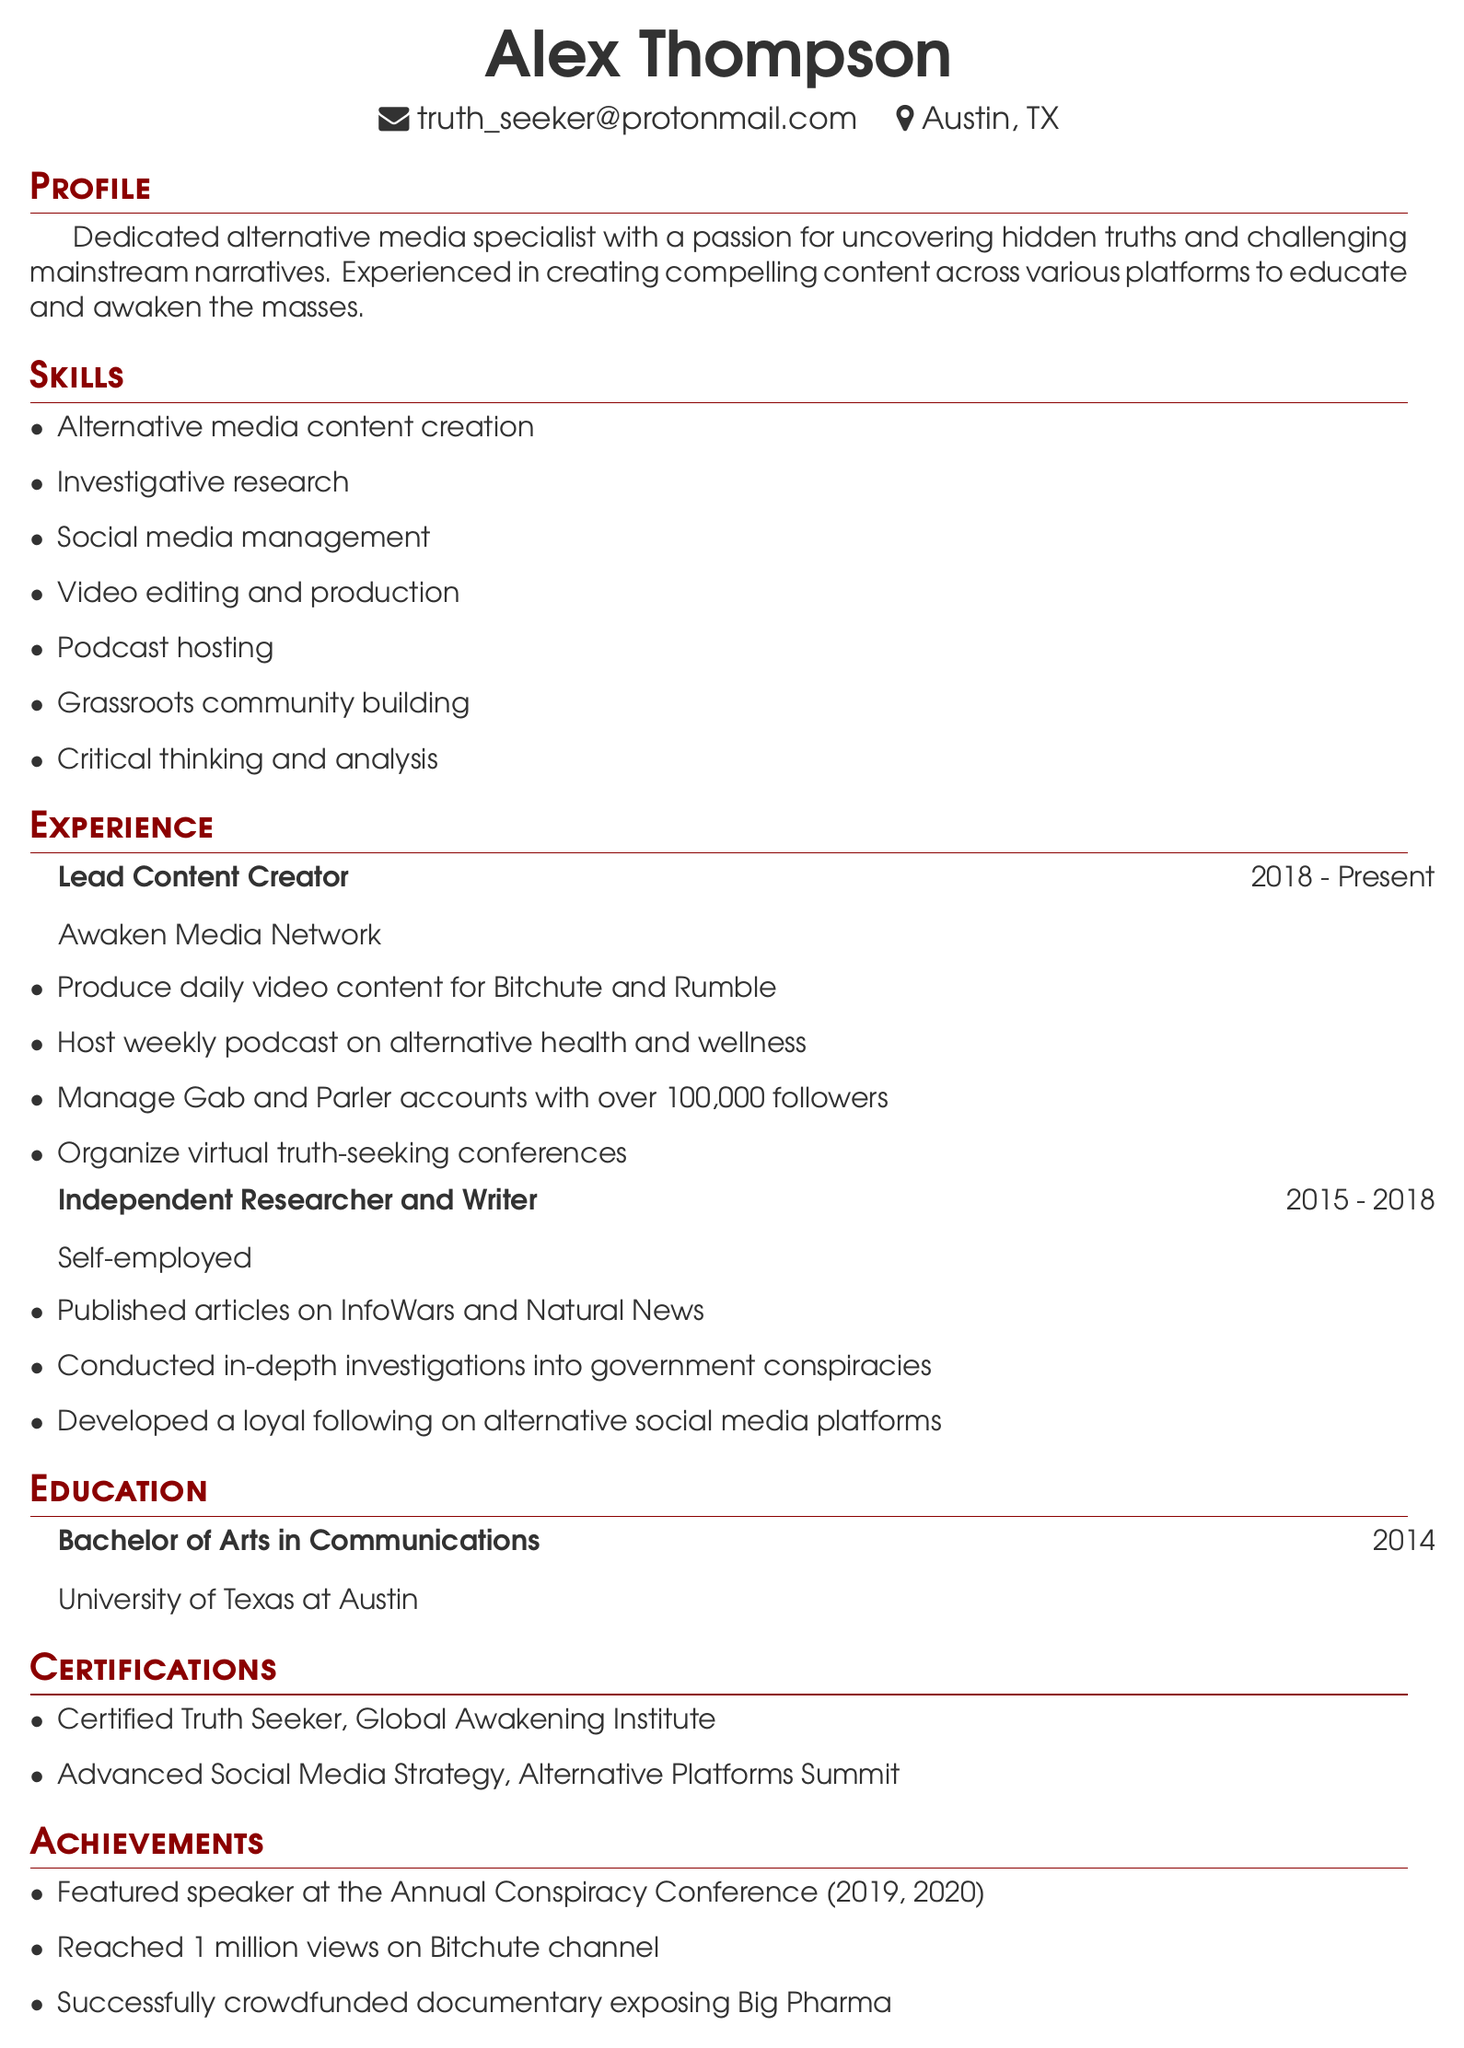What is the name of the individual? The individual's name is located at the top of the document.
Answer: Alex Thompson What is the email address listed? The email address can be found in the personal information section.
Answer: truth_seeker@protonmail.com Which organization does Alex currently work for? The current employer is mentioned in the experience section.
Answer: Awaken Media Network In which year did Alex complete their degree? The year of graduation is stated in the education section.
Answer: 2014 How long did Alex work as an Independent Researcher and Writer? The duration of this position can be calculated from the years mentioned.
Answer: 3 years What social media platforms does Alex manage? The specific platforms are listed under the responsibilities of their current role.
Answer: Gab and Parler What certification did Alex earn from the Global Awakening Institute? The certification name is provided in the certifications section.
Answer: Certified Truth Seeker What notable achievement is mentioned regarding Alex's Bitchute channel? This achievement is highlighted in the achievements section.
Answer: Reached 1 million views How many followers do Alex's Gab and Parler accounts have? The number of followers is stated in the responsibilities of the current role.
Answer: Over 100,000 followers Which conferences has Alex spoken at? The conferences where Alex was a speaker are listed in the achievements section.
Answer: Annual Conspiracy Conference 